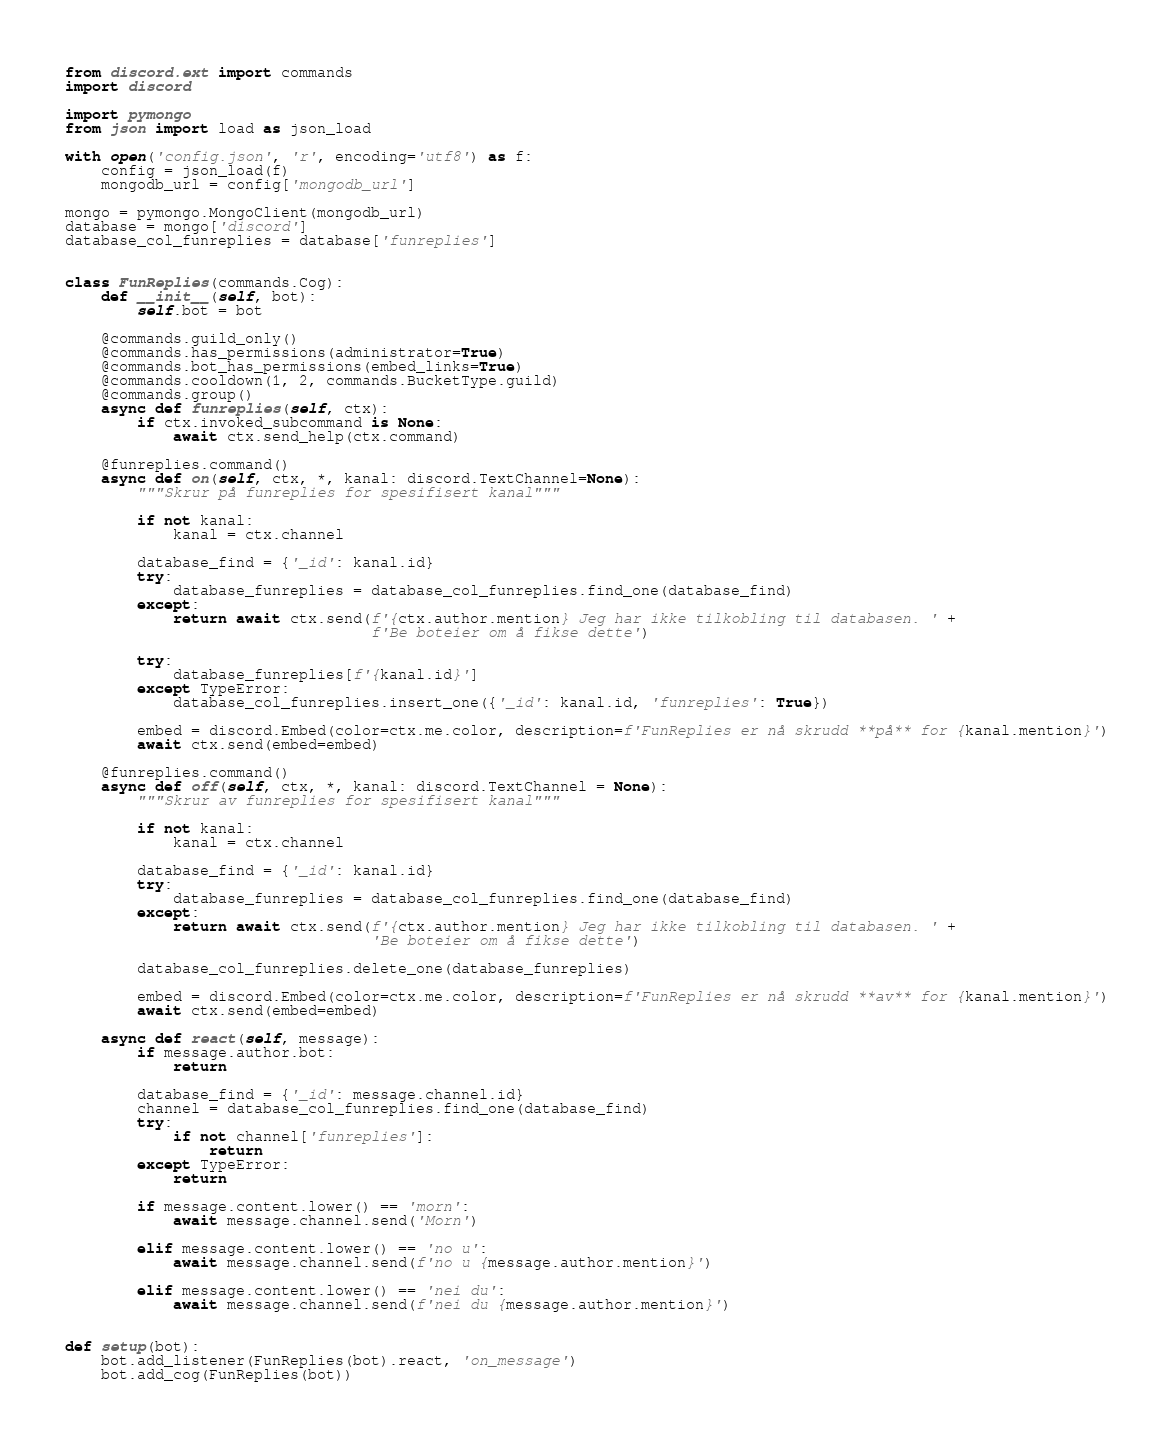Convert code to text. <code><loc_0><loc_0><loc_500><loc_500><_Python_>from discord.ext import commands
import discord

import pymongo
from json import load as json_load

with open('config.json', 'r', encoding='utf8') as f:
    config = json_load(f)
    mongodb_url = config['mongodb_url']

mongo = pymongo.MongoClient(mongodb_url)
database = mongo['discord']
database_col_funreplies = database['funreplies']


class FunReplies(commands.Cog):
    def __init__(self, bot):
        self.bot = bot

    @commands.guild_only()
    @commands.has_permissions(administrator=True)
    @commands.bot_has_permissions(embed_links=True)
    @commands.cooldown(1, 2, commands.BucketType.guild)
    @commands.group()
    async def funreplies(self, ctx):
        if ctx.invoked_subcommand is None:
            await ctx.send_help(ctx.command)

    @funreplies.command()
    async def on(self, ctx, *, kanal: discord.TextChannel=None):
        """Skrur på funreplies for spesifisert kanal"""

        if not kanal:
            kanal = ctx.channel

        database_find = {'_id': kanal.id}
        try:
            database_funreplies = database_col_funreplies.find_one(database_find)
        except:
            return await ctx.send(f'{ctx.author.mention} Jeg har ikke tilkobling til databasen. ' +
                                  f'Be boteier om å fikse dette')

        try:
            database_funreplies[f'{kanal.id}']
        except TypeError:
            database_col_funreplies.insert_one({'_id': kanal.id, 'funreplies': True})

        embed = discord.Embed(color=ctx.me.color, description=f'FunReplies er nå skrudd **på** for {kanal.mention}')
        await ctx.send(embed=embed)

    @funreplies.command()
    async def off(self, ctx, *, kanal: discord.TextChannel = None):
        """Skrur av funreplies for spesifisert kanal"""

        if not kanal:
            kanal = ctx.channel

        database_find = {'_id': kanal.id}
        try:
            database_funreplies = database_col_funreplies.find_one(database_find)
        except:
            return await ctx.send(f'{ctx.author.mention} Jeg har ikke tilkobling til databasen. ' +
                                  'Be boteier om å fikse dette')

        database_col_funreplies.delete_one(database_funreplies)

        embed = discord.Embed(color=ctx.me.color, description=f'FunReplies er nå skrudd **av** for {kanal.mention}')
        await ctx.send(embed=embed)

    async def react(self, message):
        if message.author.bot:
            return

        database_find = {'_id': message.channel.id}
        channel = database_col_funreplies.find_one(database_find)
        try:
            if not channel['funreplies']:
                return
        except TypeError:
            return

        if message.content.lower() == 'morn':
            await message.channel.send('Morn')

        elif message.content.lower() == 'no u':
            await message.channel.send(f'no u {message.author.mention}')

        elif message.content.lower() == 'nei du':
            await message.channel.send(f'nei du {message.author.mention}')


def setup(bot):
    bot.add_listener(FunReplies(bot).react, 'on_message')
    bot.add_cog(FunReplies(bot))
</code> 